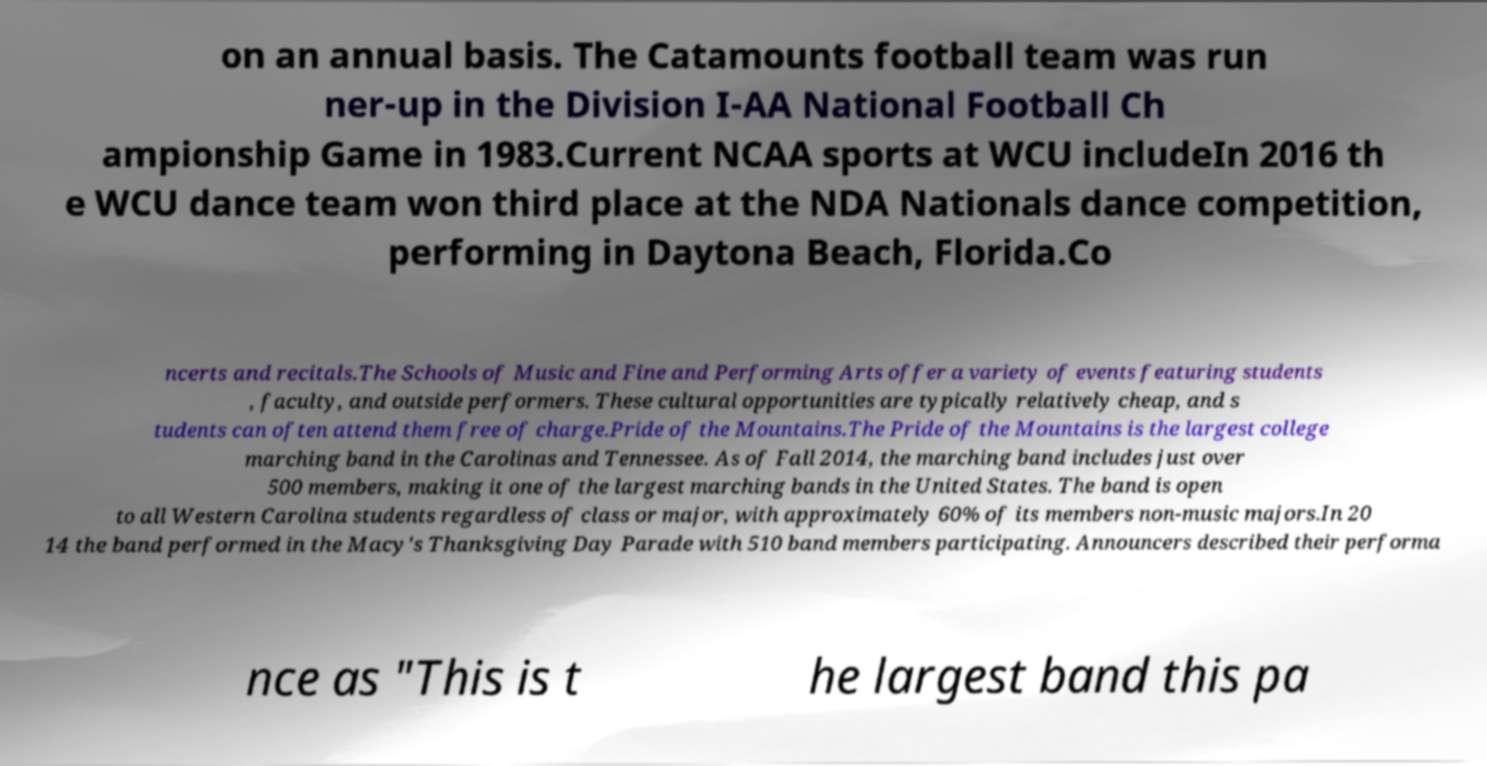I need the written content from this picture converted into text. Can you do that? on an annual basis. The Catamounts football team was run ner-up in the Division I-AA National Football Ch ampionship Game in 1983.Current NCAA sports at WCU includeIn 2016 th e WCU dance team won third place at the NDA Nationals dance competition, performing in Daytona Beach, Florida.Co ncerts and recitals.The Schools of Music and Fine and Performing Arts offer a variety of events featuring students , faculty, and outside performers. These cultural opportunities are typically relatively cheap, and s tudents can often attend them free of charge.Pride of the Mountains.The Pride of the Mountains is the largest college marching band in the Carolinas and Tennessee. As of Fall 2014, the marching band includes just over 500 members, making it one of the largest marching bands in the United States. The band is open to all Western Carolina students regardless of class or major, with approximately 60% of its members non-music majors.In 20 14 the band performed in the Macy's Thanksgiving Day Parade with 510 band members participating. Announcers described their performa nce as "This is t he largest band this pa 